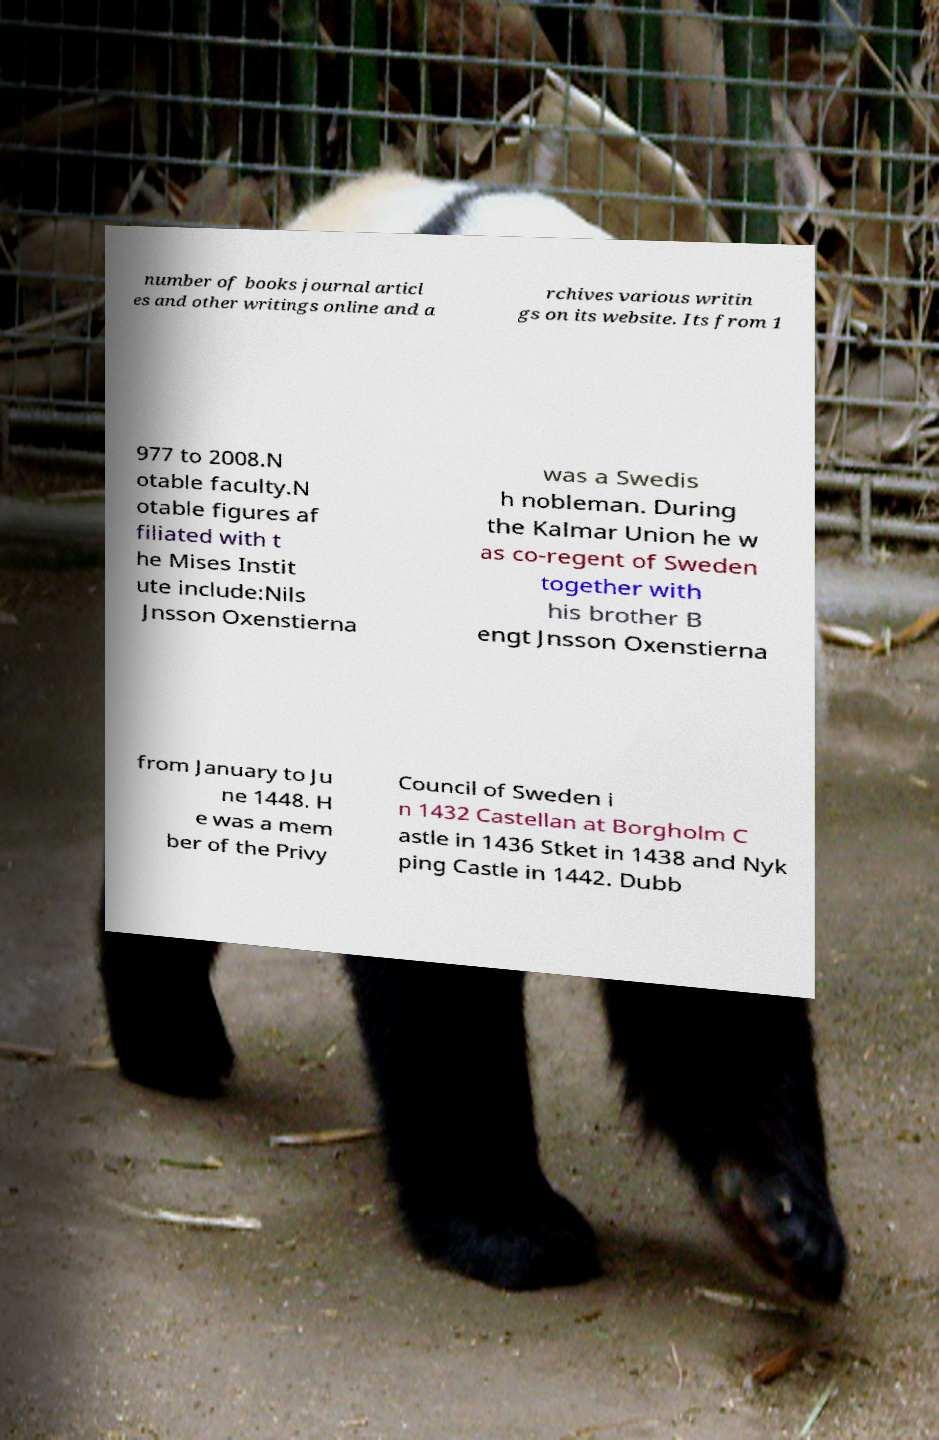I need the written content from this picture converted into text. Can you do that? number of books journal articl es and other writings online and a rchives various writin gs on its website. Its from 1 977 to 2008.N otable faculty.N otable figures af filiated with t he Mises Instit ute include:Nils Jnsson Oxenstierna was a Swedis h nobleman. During the Kalmar Union he w as co-regent of Sweden together with his brother B engt Jnsson Oxenstierna from January to Ju ne 1448. H e was a mem ber of the Privy Council of Sweden i n 1432 Castellan at Borgholm C astle in 1436 Stket in 1438 and Nyk ping Castle in 1442. Dubb 